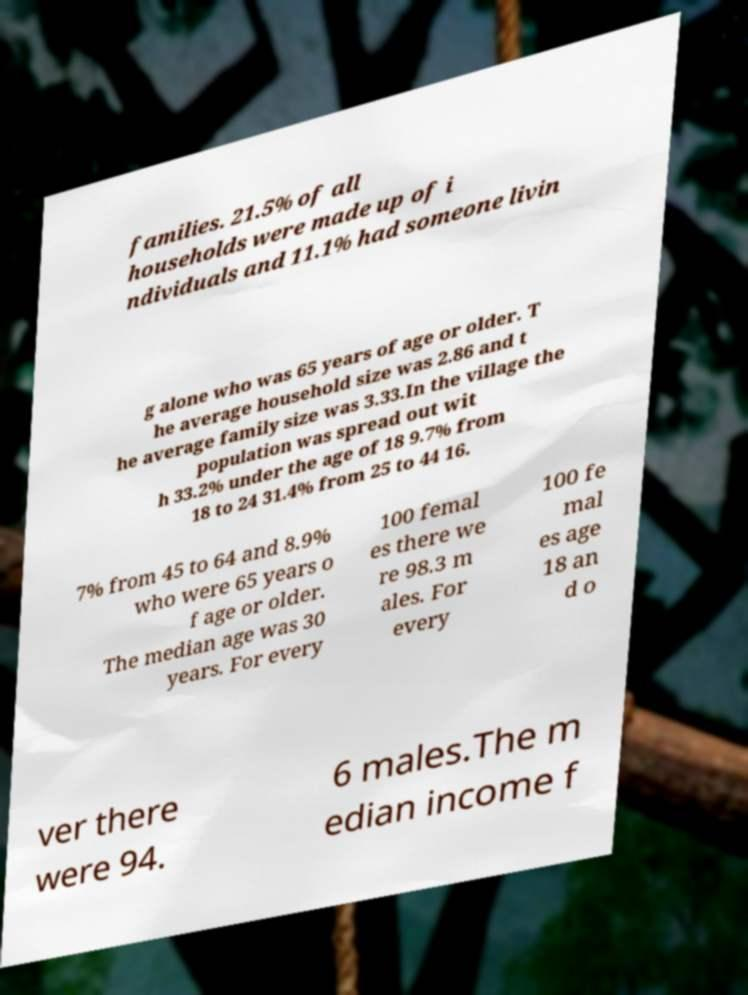Please identify and transcribe the text found in this image. families. 21.5% of all households were made up of i ndividuals and 11.1% had someone livin g alone who was 65 years of age or older. T he average household size was 2.86 and t he average family size was 3.33.In the village the population was spread out wit h 33.2% under the age of 18 9.7% from 18 to 24 31.4% from 25 to 44 16. 7% from 45 to 64 and 8.9% who were 65 years o f age or older. The median age was 30 years. For every 100 femal es there we re 98.3 m ales. For every 100 fe mal es age 18 an d o ver there were 94. 6 males.The m edian income f 